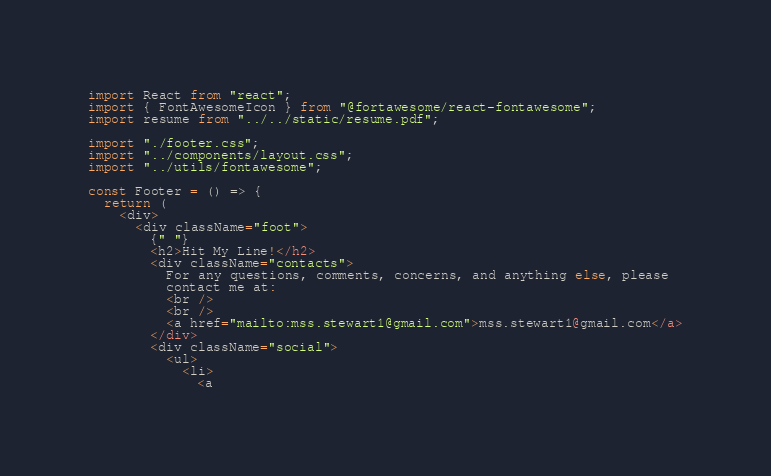<code> <loc_0><loc_0><loc_500><loc_500><_JavaScript_>import React from "react";
import { FontAwesomeIcon } from "@fortawesome/react-fontawesome";
import resume from "../../static/resume.pdf";

import "./footer.css";
import "../components/layout.css";
import "../utils/fontawesome";

const Footer = () => {
  return (
    <div>
      <div className="foot">
        {" "}
        <h2>Hit My Line!</h2>
        <div className="contacts">
          For any questions, comments, concerns, and anything else, please
          contact me at:
          <br />
          <br />
          <a href="mailto:mss.stewart1@gmail.com">mss.stewart1@gmail.com</a>
        </div>
        <div className="social">
          <ul>
            <li>
              <a</code> 